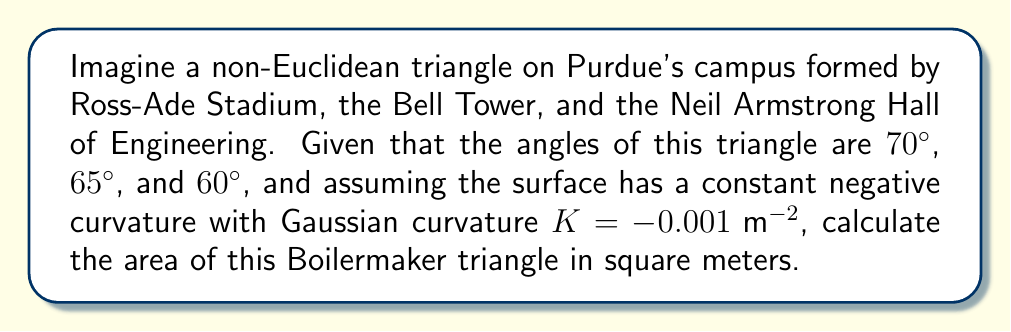Could you help me with this problem? Let's approach this step-by-step using the Gauss-Bonnet formula for hyperbolic geometry:

1) The Gauss-Bonnet formula for a hyperbolic triangle states:
   $$A = \frac{\alpha + \beta + \gamma - \pi}{-K}$$
   where $A$ is the area, $\alpha$, $\beta$, and $\gamma$ are the angles, and $K$ is the Gaussian curvature.

2) Convert the given angles to radians:
   $$70° = \frac{70\pi}{180} \text{ rad}$$
   $$65° = \frac{65\pi}{180} \text{ rad}$$
   $$60° = \frac{60\pi}{180} \text{ rad}$$

3) Sum the angles:
   $$\frac{70\pi}{180} + \frac{65\pi}{180} + \frac{60\pi}{180} = \frac{195\pi}{180} \text{ rad}$$

4) Subtract $\pi$ from this sum:
   $$\frac{195\pi}{180} - \pi = \frac{15\pi}{180} \text{ rad}$$

5) Divide by $-K = 0.001 \text{ m}^{-2}$:
   $$A = \frac{\frac{15\pi}{180}}{0.001} = 15000\pi \text{ m}^2$$

6) Simplify:
   $$A \approx 47123.89 \text{ m}^2$$
Answer: $47123.89 \text{ m}^2$ 